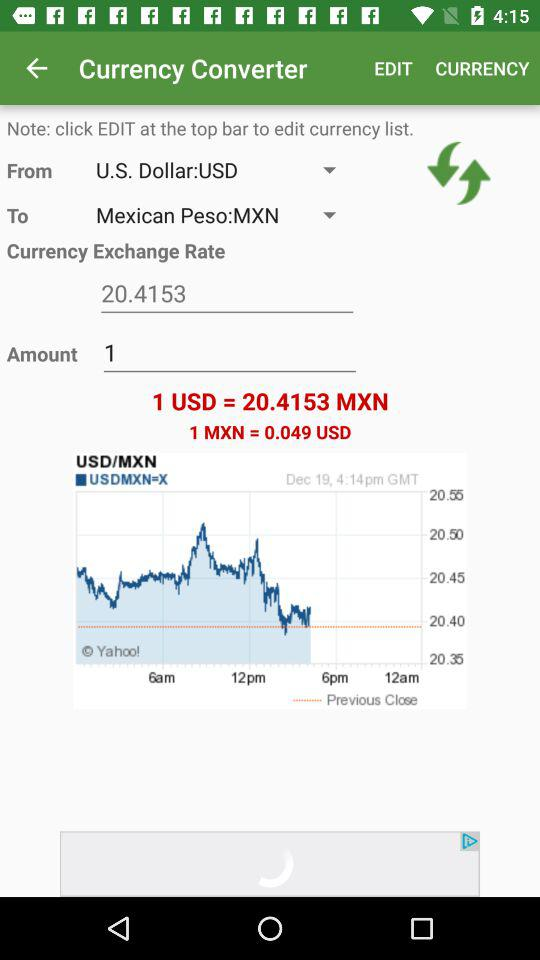What is the exchange rate between U.S. Dollar and Mexican Peso?
Answer the question using a single word or phrase. 1 USD = 20.4153 MXN 